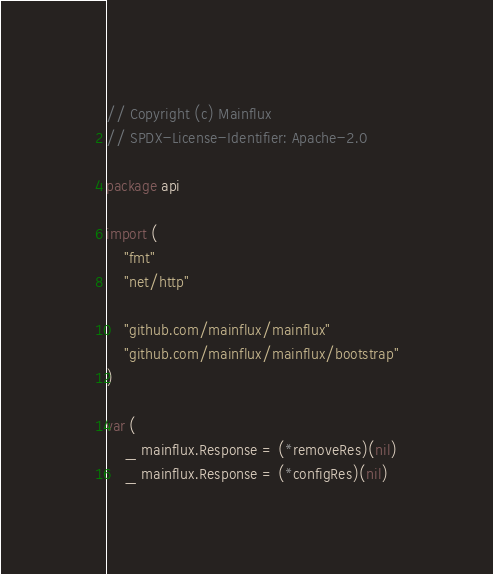Convert code to text. <code><loc_0><loc_0><loc_500><loc_500><_Go_>// Copyright (c) Mainflux
// SPDX-License-Identifier: Apache-2.0

package api

import (
	"fmt"
	"net/http"

	"github.com/mainflux/mainflux"
	"github.com/mainflux/mainflux/bootstrap"
)

var (
	_ mainflux.Response = (*removeRes)(nil)
	_ mainflux.Response = (*configRes)(nil)</code> 